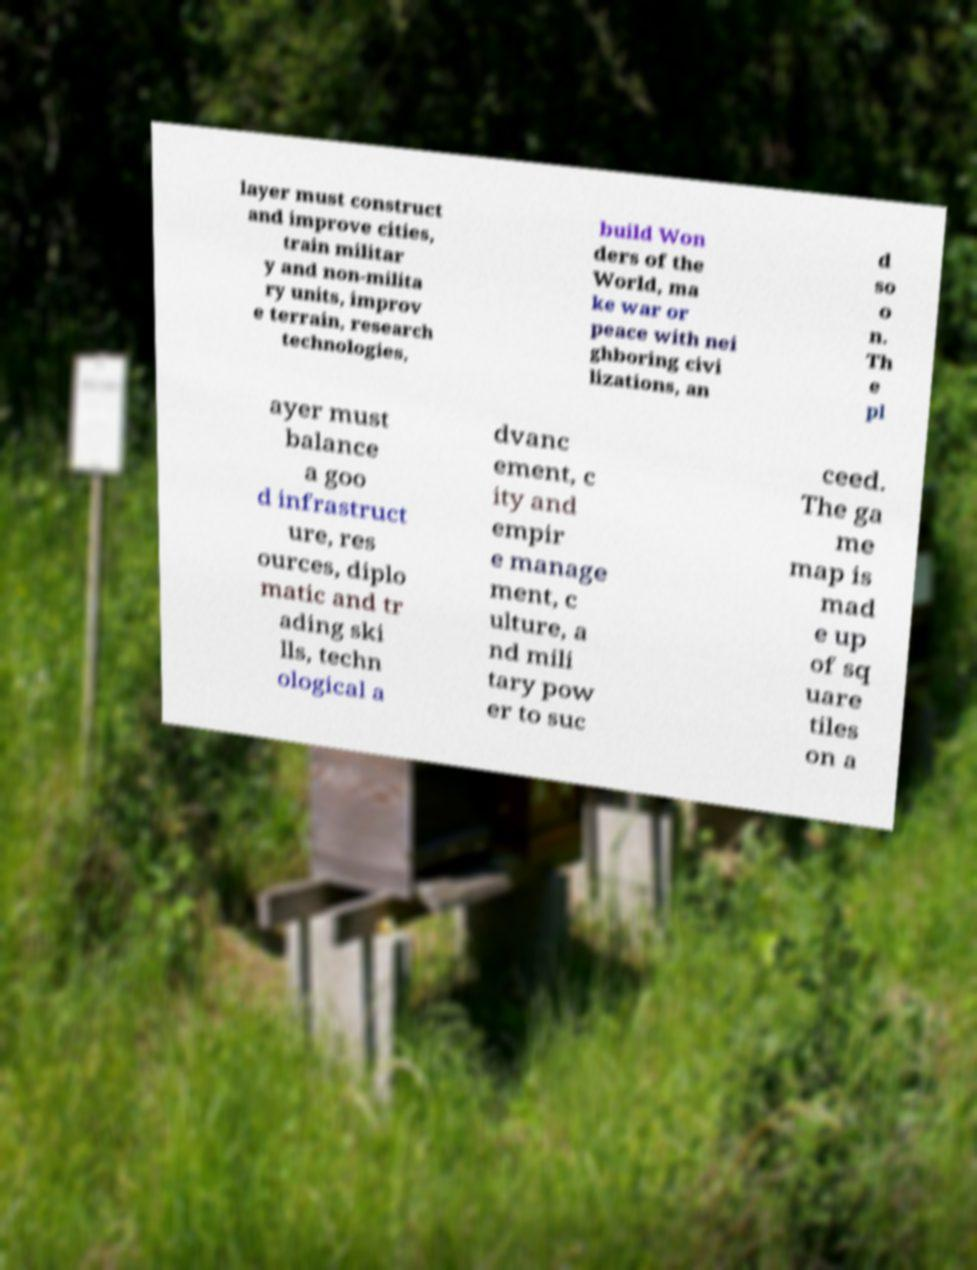Could you assist in decoding the text presented in this image and type it out clearly? layer must construct and improve cities, train militar y and non-milita ry units, improv e terrain, research technologies, build Won ders of the World, ma ke war or peace with nei ghboring civi lizations, an d so o n. Th e pl ayer must balance a goo d infrastruct ure, res ources, diplo matic and tr ading ski lls, techn ological a dvanc ement, c ity and empir e manage ment, c ulture, a nd mili tary pow er to suc ceed. The ga me map is mad e up of sq uare tiles on a 